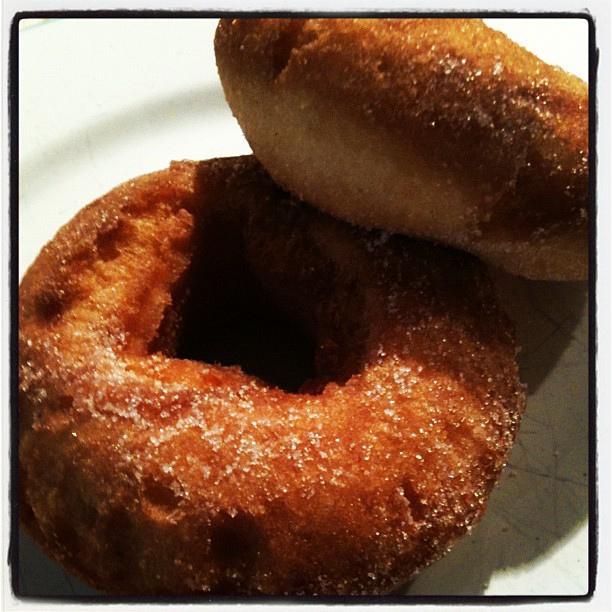What are these?
Quick response, please. Donuts. What is sprinkled on these?
Answer briefly. Sugar. What color is the background?
Give a very brief answer. White. 